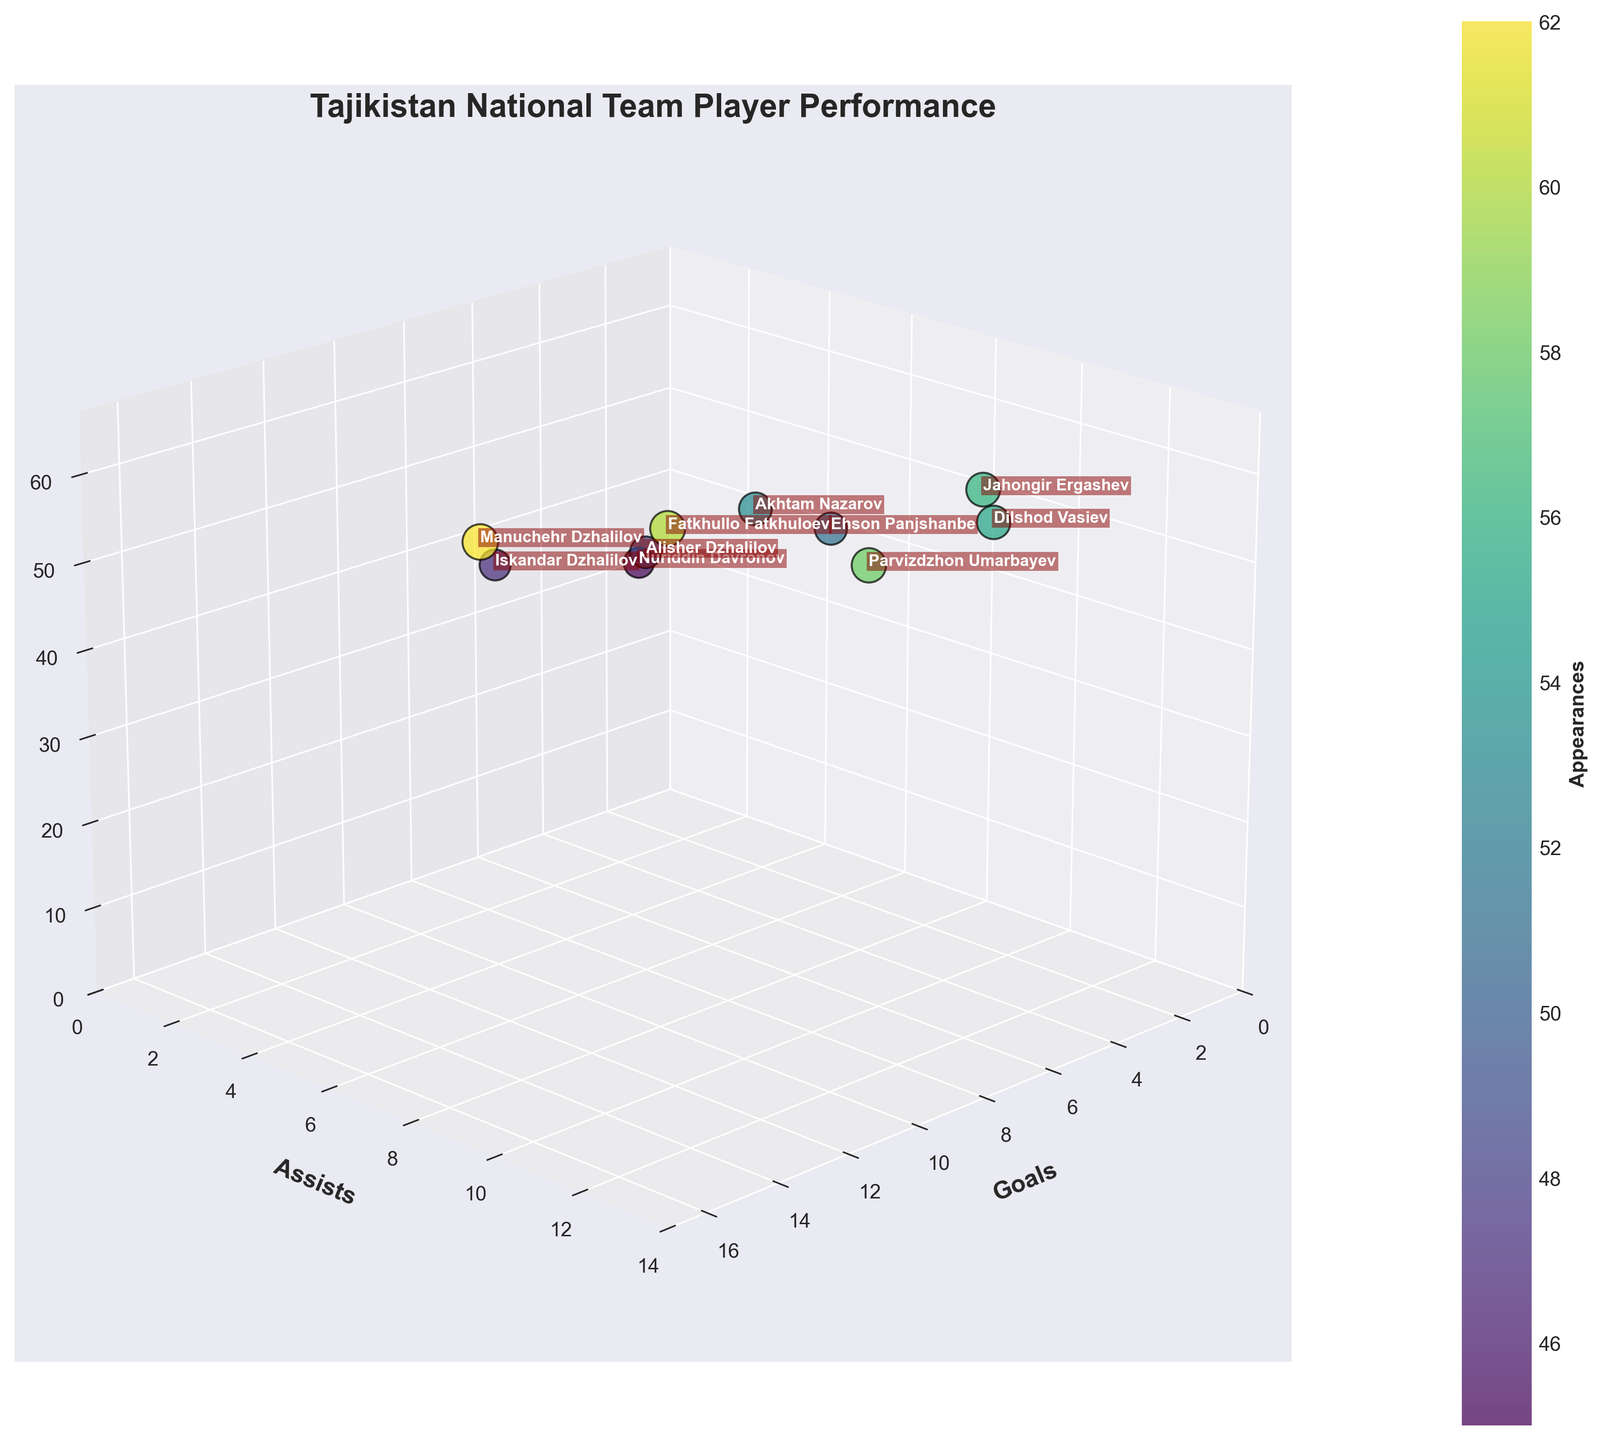How many players have more than 10 assists? There are two players: Parvizdzhon Umarbayev with 12 assists, and Dilshod Vasiev, also with 11 assists.
Answer: 2 Which player scored the most goals? Manuchehr Dzhalilov has the highest number of goals with 15. You can see his data point furthest along the goals axis.
Answer: Manuchehr Dzhalilov What is the total number of appearances for the players with at least 10 assists? The players with at least 10 assists are Parvizdzhon Umarbayev (58 appearances) and Jahongir Ergashev (56 appearances). Summing them, 58 + 56 = 114.
Answer: 114 Who has the least goals and how many does he have? Jahongir Ergashev has the least goals, with 3. You can find his data point closest to the origin in the goals axis.
Answer: Jahongir Ergashev Which three players have the closest appearance counts? The appearance counts closest to each other are Jahongir Ergashev (56), Dilshod Vasiev (55), and Akhtam Nazarov (53).
Answer: Jahongir Ergashev, Dilshod Vasiev, Akhtam Nazarov Are there any players with the same number of assists? No, all players have different numbers of assists; each data point is unique along the assists axis.
Answer: No Compare the players with the highest and lowest goals in terms of their assists. Manuchehr Dzhalilov has the highest goals (15) and 8 assists. Jahongir Ergashev has the lowest goals (3) and 10 assists. Their assists differ, with Ergashev having 2 more assists than Dzhalilov.
Answer: 2 more assists What's the average number of goals scored by all players? Summing the goals scored (15, 9, 7, 6, 11, 8, 4, 10, 5, 3) equates to 78. Dividing by the number of players (10) gives the average: 78 / 10 = 7.8.
Answer: 7.8 Who has more appearances, Parvizdzhon Umarbayev or Manuchehr Dzhalilov? By how many? Manuchehr Dzhalilov has 62 appearances, while Parvizdzhon Umarbayev has 58. The difference is 62 - 58 = 4.
Answer: Manuchehr Dzhalilov by 4 Which player is represented by a data point with a label that includes a dark red background? All players' data points are labeled with text that includes dark red backgrounds, as per the plot annotation style described.
Answer: All 